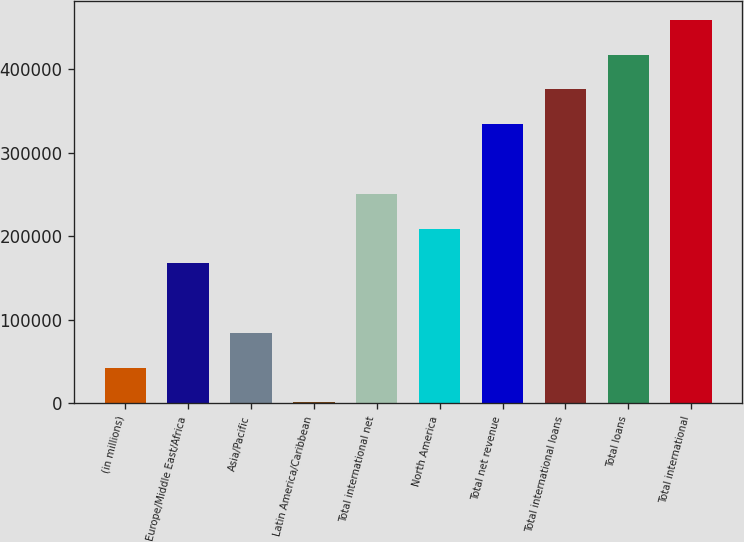<chart> <loc_0><loc_0><loc_500><loc_500><bar_chart><fcel>(in millions)<fcel>Europe/Middle East/Africa<fcel>Asia/Pacific<fcel>Latin America/Caribbean<fcel>Total international net<fcel>North America<fcel>Total net revenue<fcel>Total international loans<fcel>Total loans<fcel>Total international<nl><fcel>42798<fcel>167655<fcel>84417<fcel>1179<fcel>250893<fcel>209274<fcel>334131<fcel>375750<fcel>417369<fcel>458988<nl></chart> 